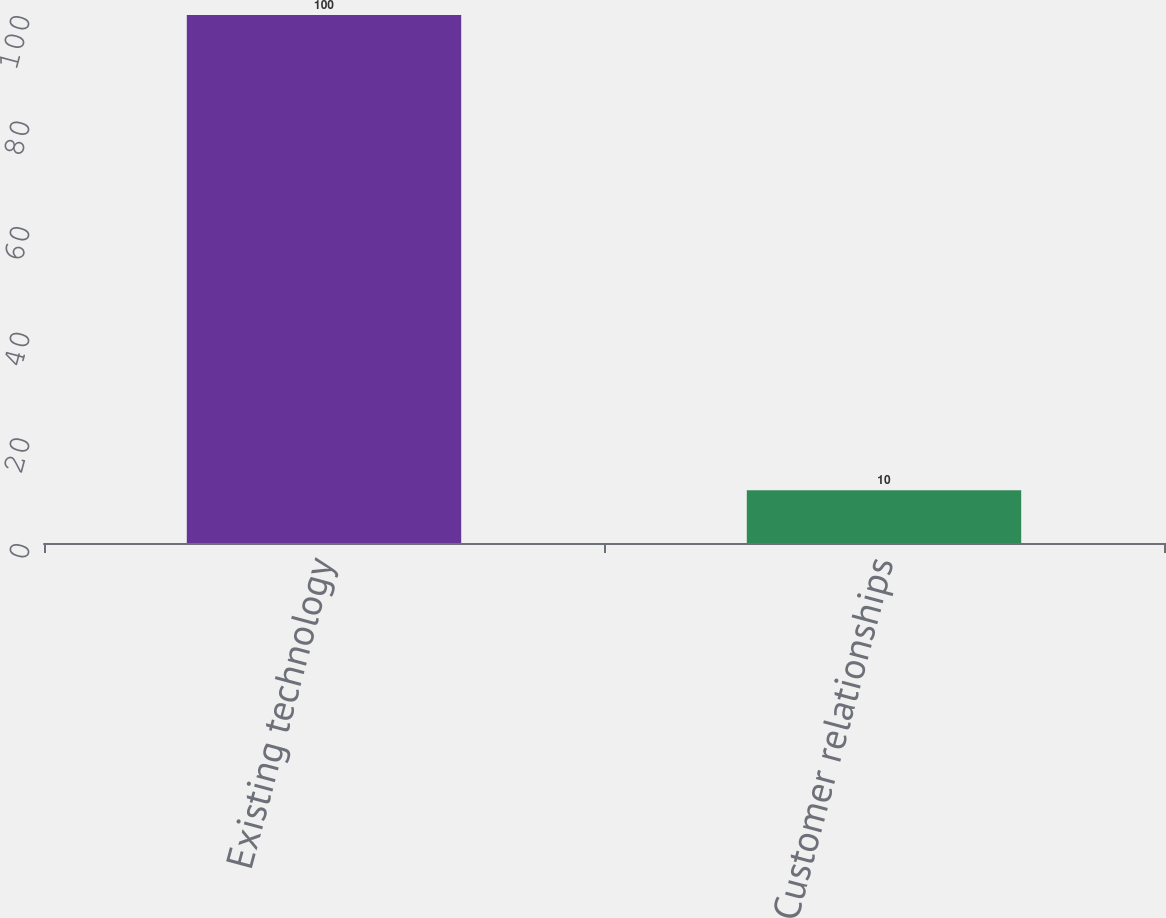Convert chart to OTSL. <chart><loc_0><loc_0><loc_500><loc_500><bar_chart><fcel>Existing technology<fcel>Customer relationships<nl><fcel>100<fcel>10<nl></chart> 